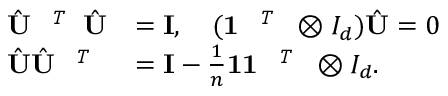<formula> <loc_0><loc_0><loc_500><loc_500>\begin{array} { r l } { \hat { U } ^ { T } \hat { U } } & { = { I } , \quad ( 1 ^ { T } \otimes I _ { d } ) \hat { U } = 0 } \\ { \hat { U } \hat { U } ^ { T } } & { = { I } - \frac { 1 } { n } 1 1 ^ { T } \otimes I _ { d } . } \end{array}</formula> 